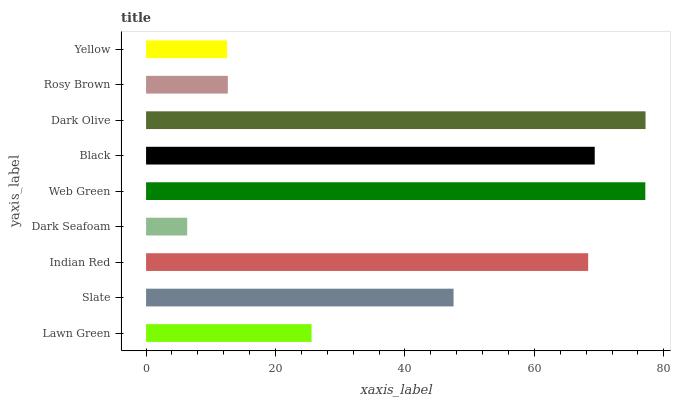Is Dark Seafoam the minimum?
Answer yes or no. Yes. Is Dark Olive the maximum?
Answer yes or no. Yes. Is Slate the minimum?
Answer yes or no. No. Is Slate the maximum?
Answer yes or no. No. Is Slate greater than Lawn Green?
Answer yes or no. Yes. Is Lawn Green less than Slate?
Answer yes or no. Yes. Is Lawn Green greater than Slate?
Answer yes or no. No. Is Slate less than Lawn Green?
Answer yes or no. No. Is Slate the high median?
Answer yes or no. Yes. Is Slate the low median?
Answer yes or no. Yes. Is Indian Red the high median?
Answer yes or no. No. Is Dark Seafoam the low median?
Answer yes or no. No. 